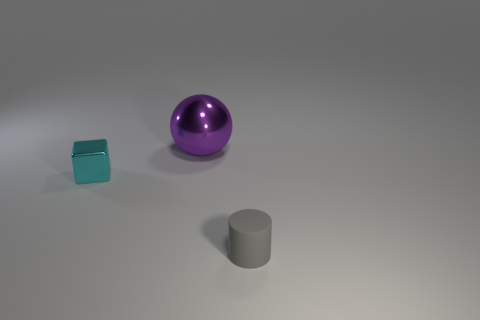Add 1 big brown metal spheres. How many objects exist? 4 Subtract all spheres. How many objects are left? 2 Subtract 0 purple blocks. How many objects are left? 3 Subtract all tiny cyan things. Subtract all small cyan metal blocks. How many objects are left? 1 Add 2 purple metal things. How many purple metal things are left? 3 Add 2 tiny metallic blocks. How many tiny metallic blocks exist? 3 